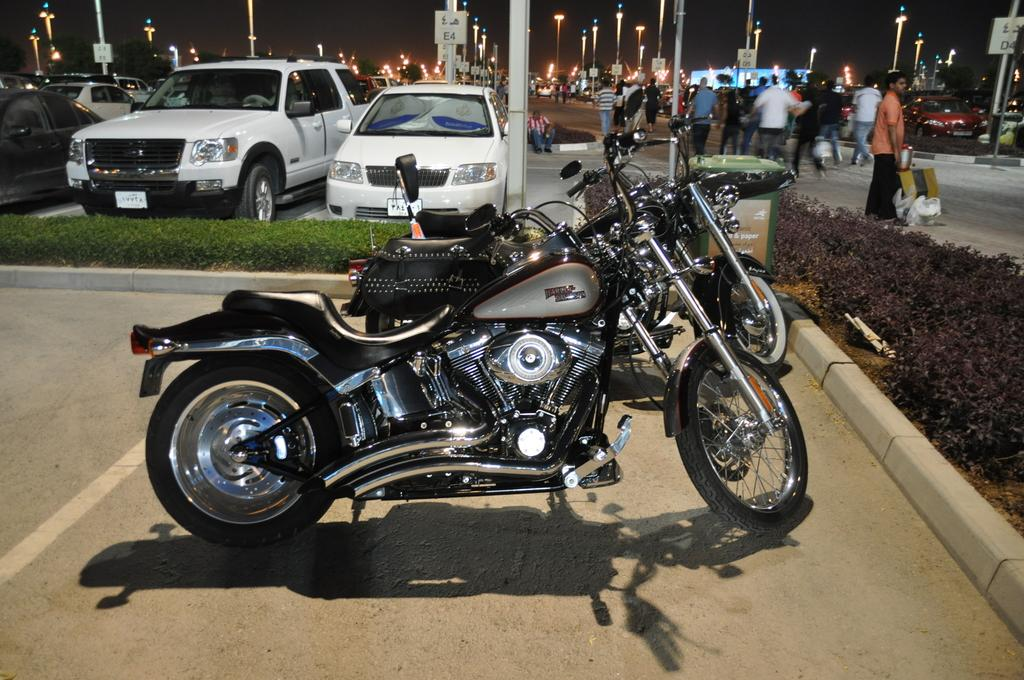How many bikes can be seen in the image? There are two bikes in the image. What is located behind the bikes? Cars are present behind the bikes. What are the people in the image doing? Humans are walking on the road. What type of vegetation is visible on the right side of the image? Plants are visible on the right side of the image. What type of oatmeal is being served to the people walking on the road? There is no oatmeal present in the image; people are walking on the road. What is causing the people walking on the road to laugh? There is no indication of laughter in the image; people are simply walking on the road. 